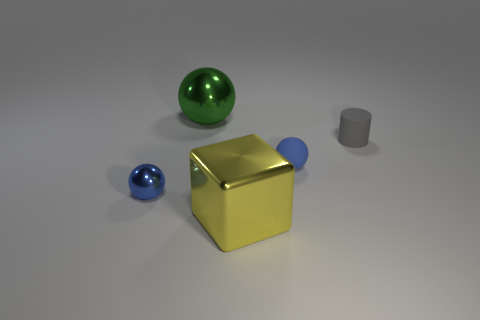What is the shape of the matte object that is the same color as the small metallic ball?
Give a very brief answer. Sphere. Is the size of the gray thing the same as the yellow object?
Make the answer very short. No. Is there any other thing of the same color as the small rubber cylinder?
Make the answer very short. No. What shape is the metal object that is both in front of the tiny cylinder and on the right side of the small blue metallic thing?
Offer a very short reply. Cube. What size is the blue ball that is to the right of the big green metallic object?
Offer a very short reply. Small. There is a metallic ball that is behind the metal ball that is in front of the large green shiny thing; what number of blue metal spheres are behind it?
Offer a very short reply. 0. There is a yellow metallic object; are there any matte things to the left of it?
Provide a succinct answer. No. How many other things are there of the same size as the blue matte ball?
Your response must be concise. 2. There is a small thing that is both on the right side of the big cube and left of the gray cylinder; what material is it made of?
Ensure brevity in your answer.  Rubber. Is the shape of the large metal object behind the yellow shiny cube the same as the tiny blue thing behind the tiny blue shiny sphere?
Offer a terse response. Yes. 